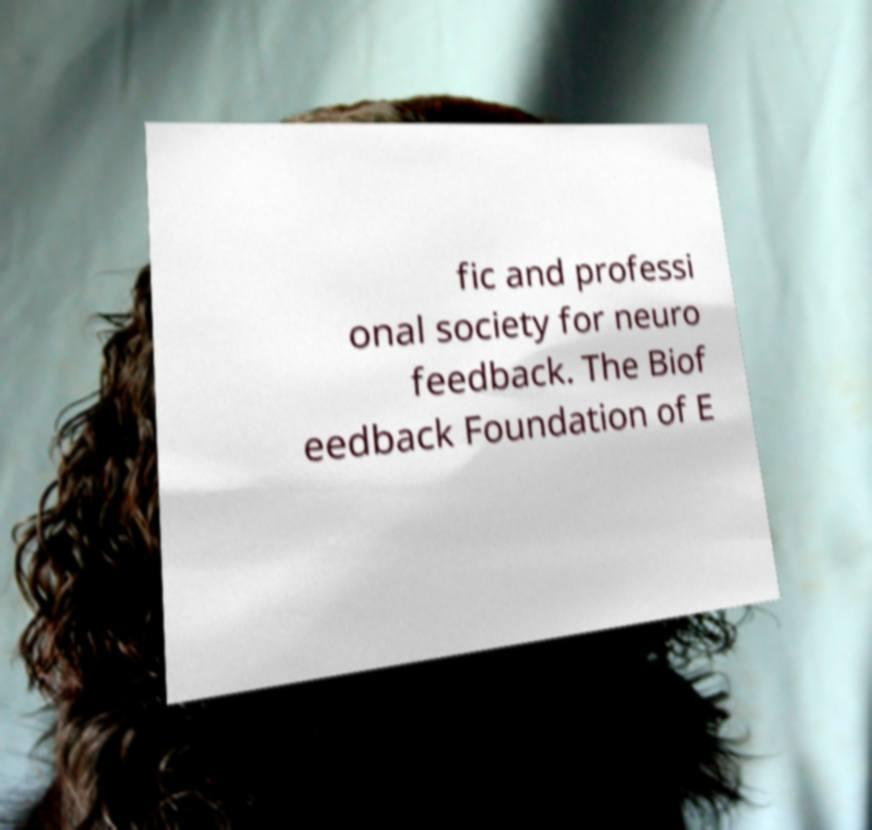Please read and relay the text visible in this image. What does it say? fic and professi onal society for neuro feedback. The Biof eedback Foundation of E 